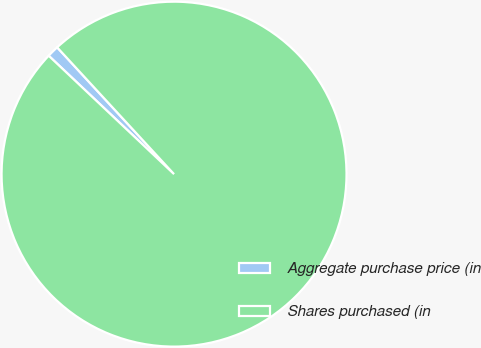<chart> <loc_0><loc_0><loc_500><loc_500><pie_chart><fcel>Aggregate purchase price (in<fcel>Shares purchased (in<nl><fcel>1.1%<fcel>98.9%<nl></chart> 